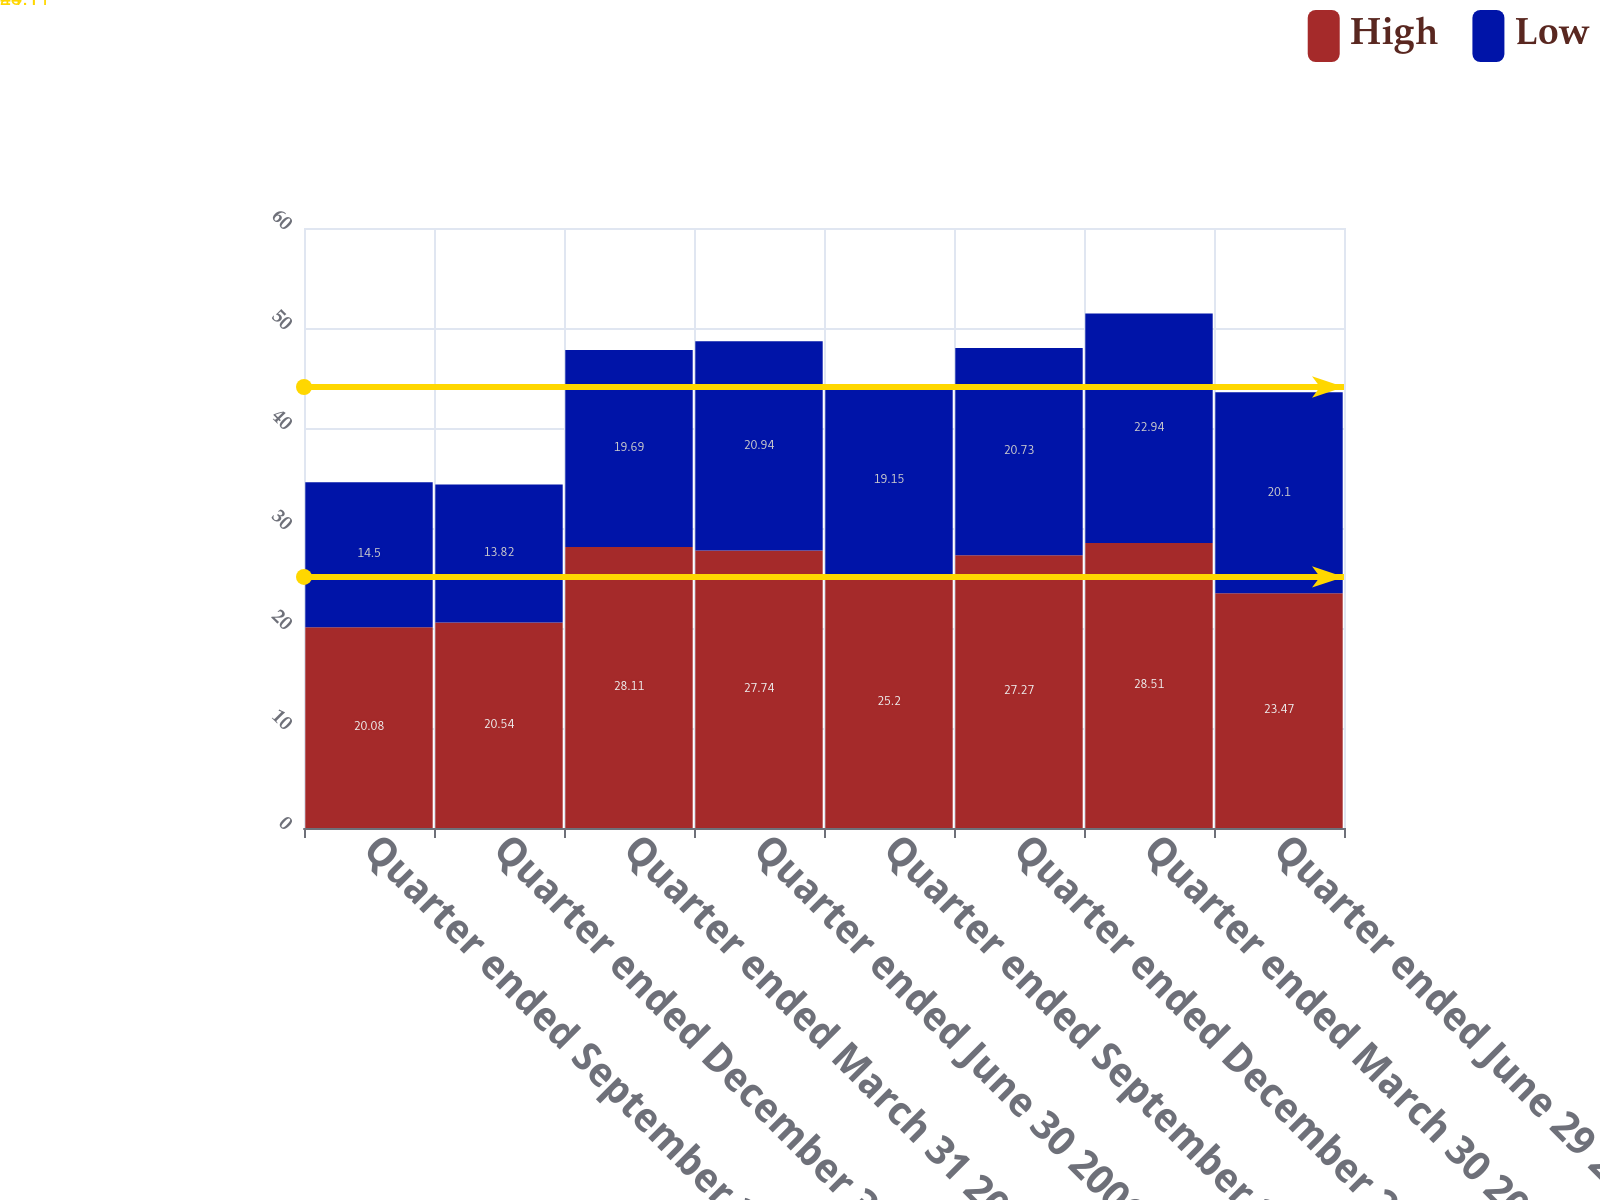Convert chart to OTSL. <chart><loc_0><loc_0><loc_500><loc_500><stacked_bar_chart><ecel><fcel>Quarter ended September 30<fcel>Quarter ended December 30 2005<fcel>Quarter ended March 31 2006<fcel>Quarter ended June 30 2006<fcel>Quarter ended September 29<fcel>Quarter ended December 29 2006<fcel>Quarter ended March 30 2007<fcel>Quarter ended June 29 2007<nl><fcel>High<fcel>20.08<fcel>20.54<fcel>28.11<fcel>27.74<fcel>25.2<fcel>27.27<fcel>28.51<fcel>23.47<nl><fcel>Low<fcel>14.5<fcel>13.82<fcel>19.69<fcel>20.94<fcel>19.15<fcel>20.73<fcel>22.94<fcel>20.1<nl></chart> 